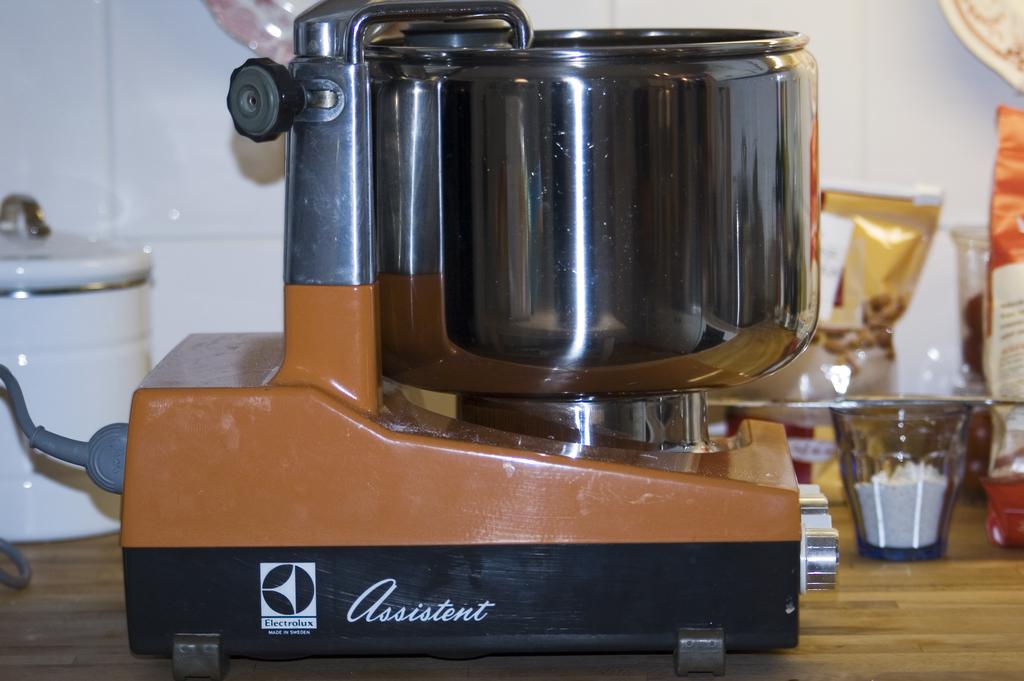What is the brand name of the device?
Provide a succinct answer. Assistent. What is the first letter of the brand?
Provide a succinct answer. A. 